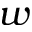<formula> <loc_0><loc_0><loc_500><loc_500>w</formula> 